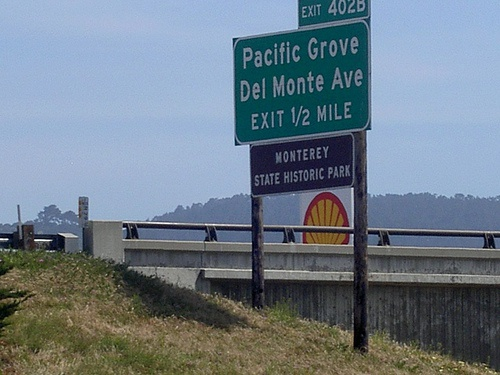Describe the objects in this image and their specific colors. I can see various objects in this image with different colors. 